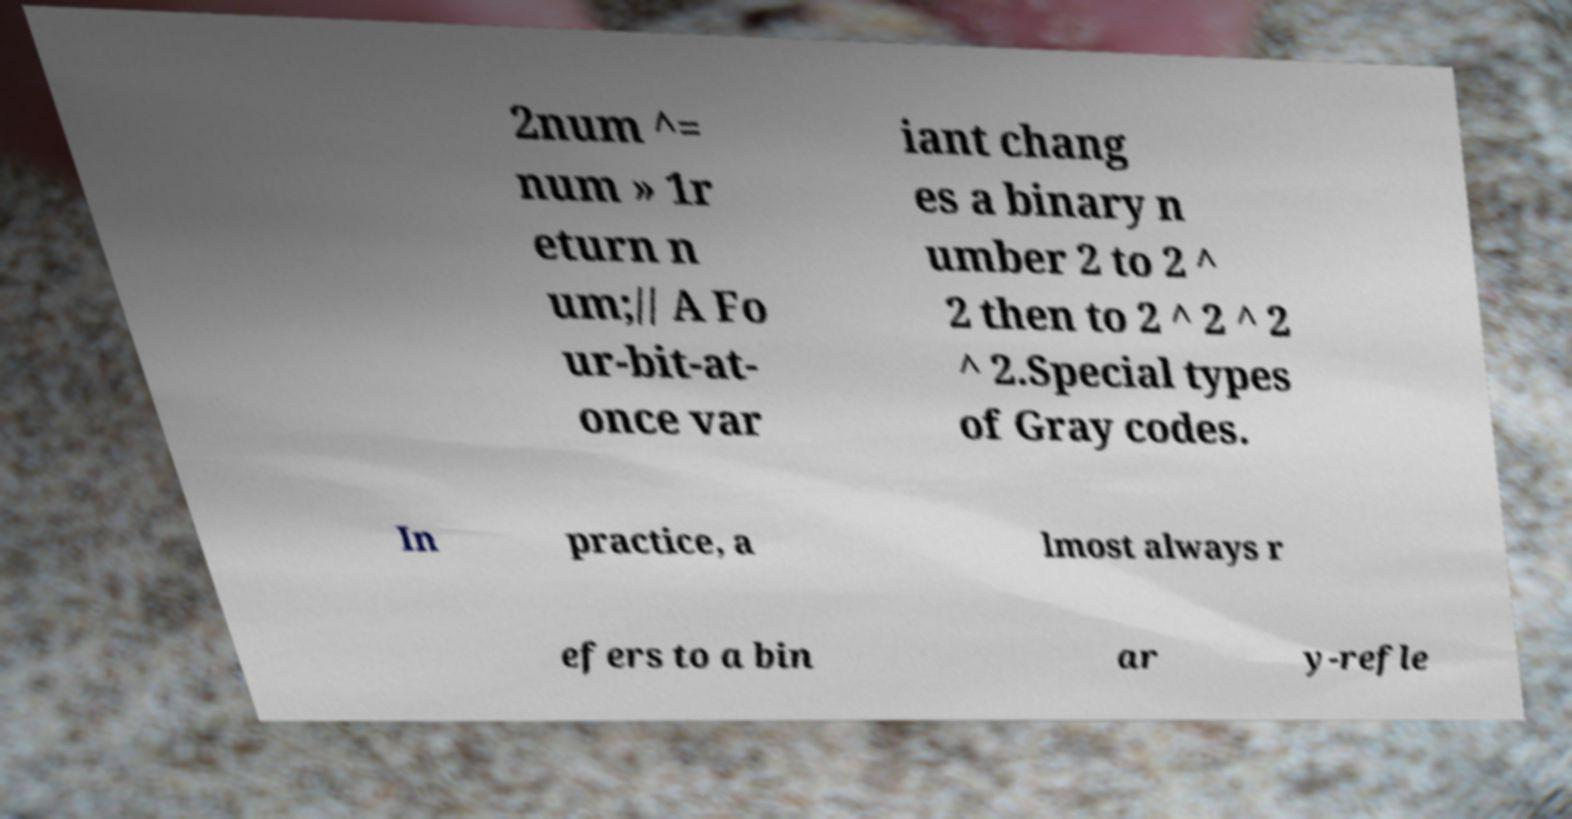For documentation purposes, I need the text within this image transcribed. Could you provide that? 2num ^= num » 1r eturn n um;// A Fo ur-bit-at- once var iant chang es a binary n umber 2 to 2 ^ 2 then to 2 ^ 2 ^ 2 ^ 2.Special types of Gray codes. In practice, a lmost always r efers to a bin ar y-refle 